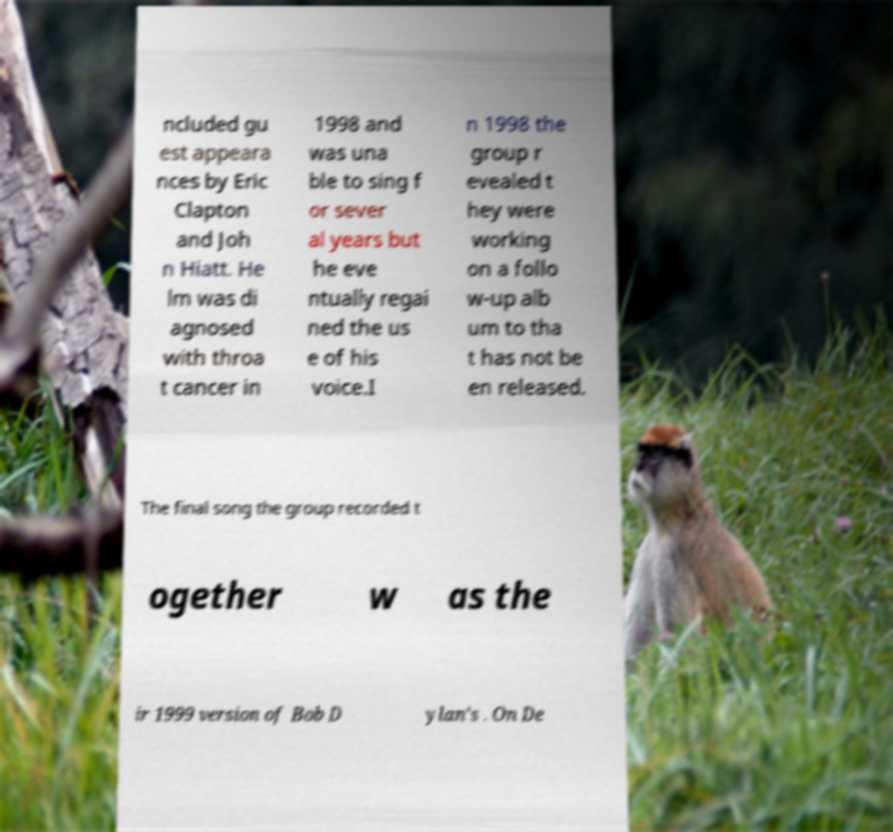Please identify and transcribe the text found in this image. ncluded gu est appeara nces by Eric Clapton and Joh n Hiatt. He lm was di agnosed with throa t cancer in 1998 and was una ble to sing f or sever al years but he eve ntually regai ned the us e of his voice.I n 1998 the group r evealed t hey were working on a follo w-up alb um to tha t has not be en released. The final song the group recorded t ogether w as the ir 1999 version of Bob D ylan's . On De 